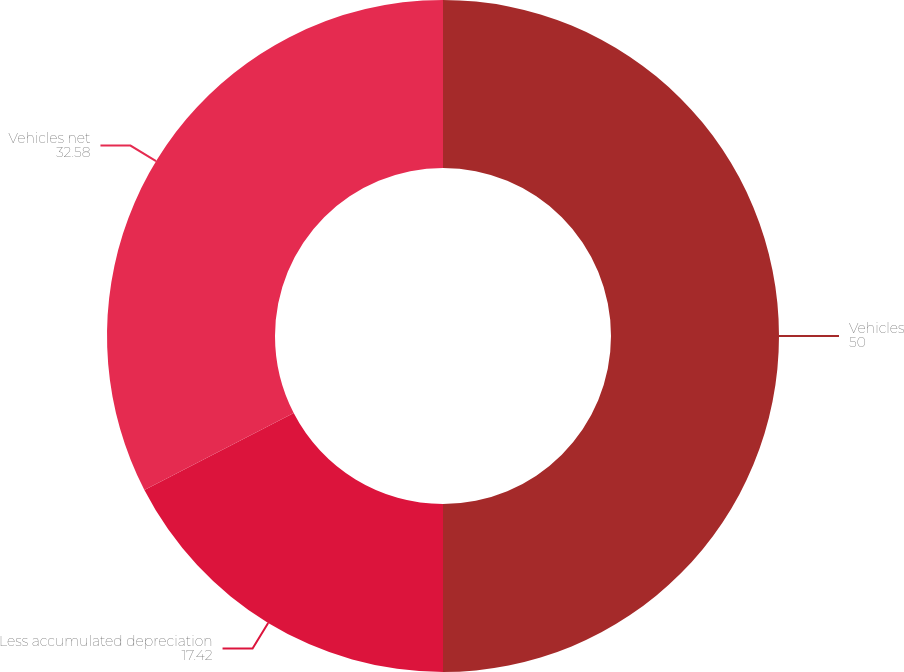Convert chart to OTSL. <chart><loc_0><loc_0><loc_500><loc_500><pie_chart><fcel>Vehicles<fcel>Less accumulated depreciation<fcel>Vehicles net<nl><fcel>50.0%<fcel>17.42%<fcel>32.58%<nl></chart> 